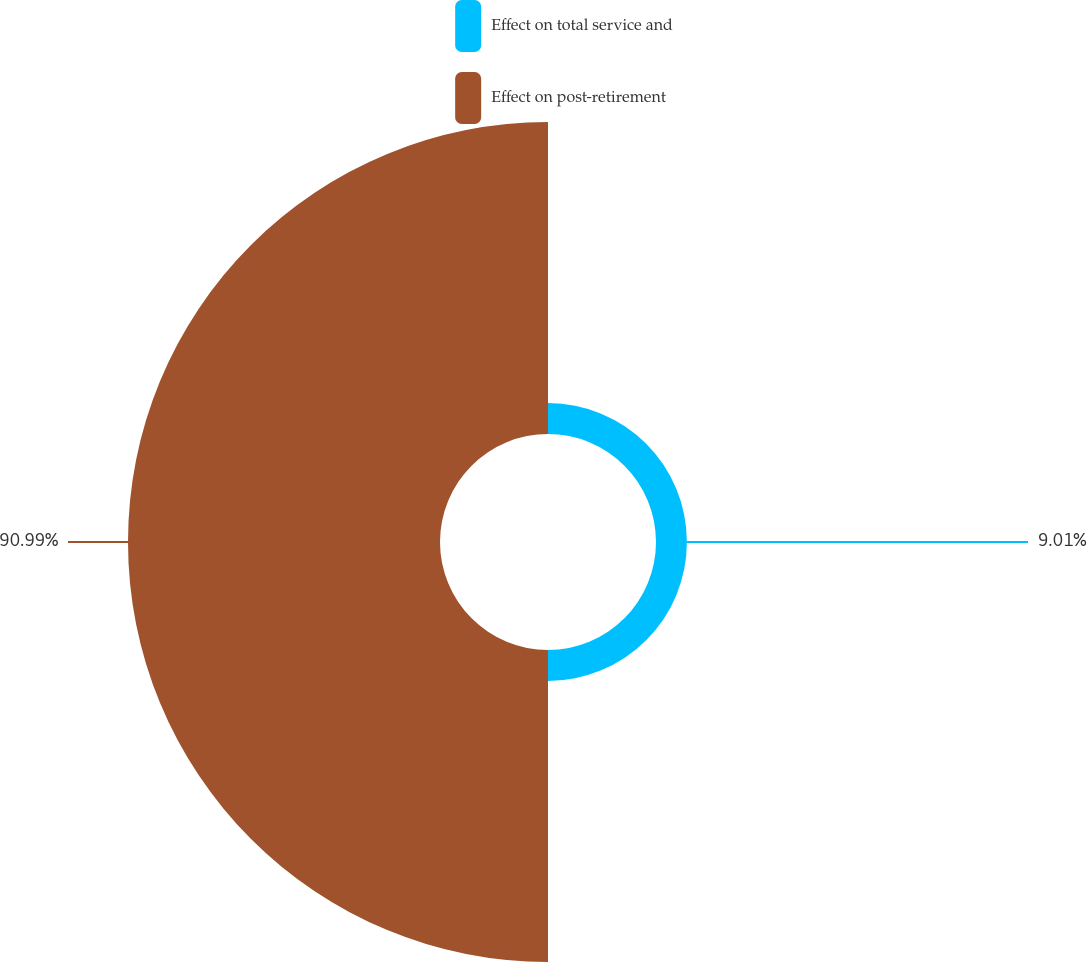Convert chart. <chart><loc_0><loc_0><loc_500><loc_500><pie_chart><fcel>Effect on total service and<fcel>Effect on post-retirement<nl><fcel>9.01%<fcel>90.99%<nl></chart> 